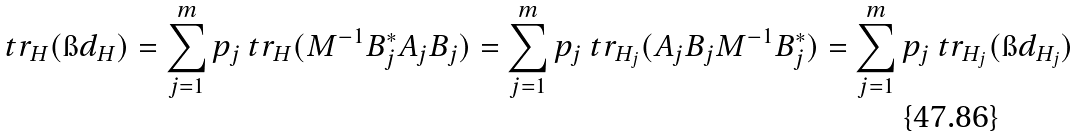Convert formula to latex. <formula><loc_0><loc_0><loc_500><loc_500>\ t r _ { H } ( \i d _ { H } ) = \sum _ { j = 1 } ^ { m } p _ { j } \ t r _ { H } ( M ^ { - 1 } B _ { j } ^ { * } A _ { j } B _ { j } ) = \sum _ { j = 1 } ^ { m } p _ { j } \ t r _ { H _ { j } } ( A _ { j } B _ { j } M ^ { - 1 } B _ { j } ^ { * } ) = \sum _ { j = 1 } ^ { m } p _ { j } \ t r _ { H _ { j } } ( \i d _ { H _ { j } } )</formula> 